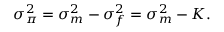Convert formula to latex. <formula><loc_0><loc_0><loc_500><loc_500>\sigma _ { \pi } ^ { 2 } = \sigma _ { m } ^ { 2 } - \sigma _ { f } ^ { 2 } = \sigma _ { m } ^ { 2 } - K .</formula> 